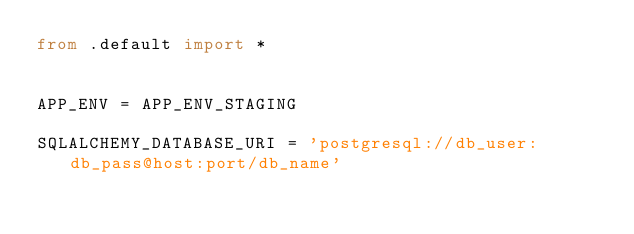Convert code to text. <code><loc_0><loc_0><loc_500><loc_500><_Python_>from .default import *


APP_ENV = APP_ENV_STAGING

SQLALCHEMY_DATABASE_URI = 'postgresql://db_user:db_pass@host:port/db_name'
</code> 